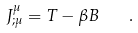<formula> <loc_0><loc_0><loc_500><loc_500>J ^ { \mu } _ { ; \mu } = T - \beta B \quad .</formula> 